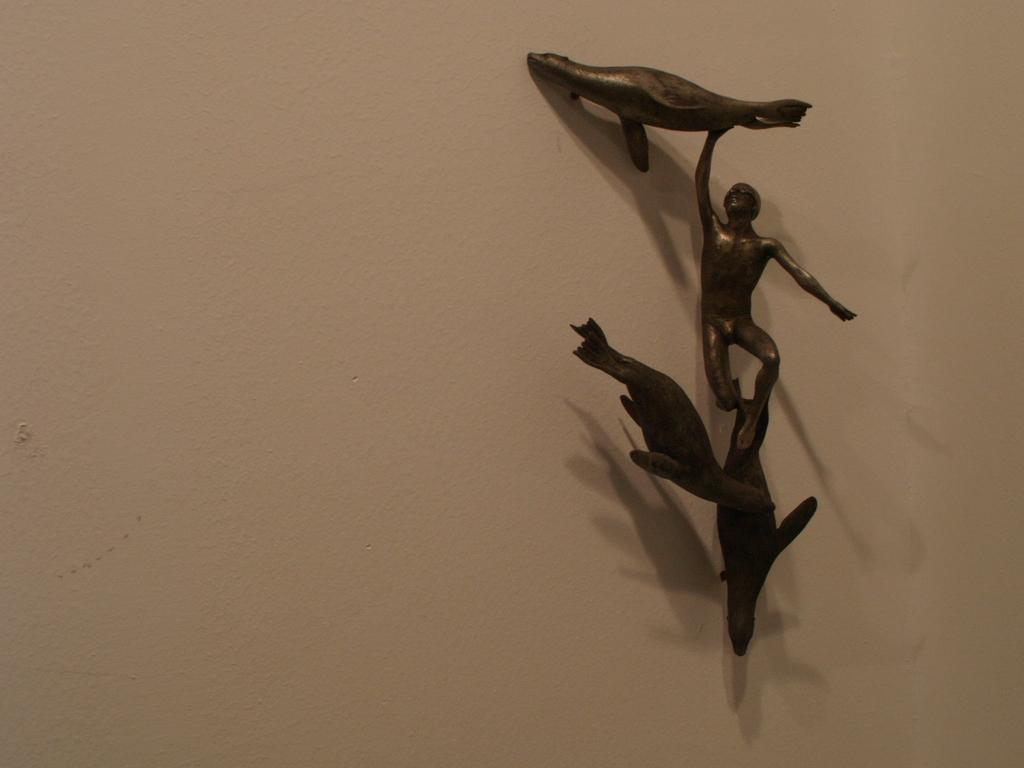What type of objects can be seen in the image? There are statues in the image. What material are the statues made of? The statues are made of metal. How are the statues positioned in the image? The statues are attached to the wall. What invention is being demonstrated by the statues in the image? There is no invention being demonstrated by the statues in the image; they are simply statues made of metal and attached to the wall. 